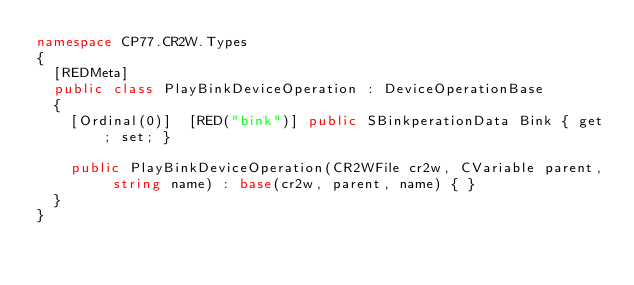Convert code to text. <code><loc_0><loc_0><loc_500><loc_500><_C#_>namespace CP77.CR2W.Types
{
	[REDMeta]
	public class PlayBinkDeviceOperation : DeviceOperationBase
	{
		[Ordinal(0)]  [RED("bink")] public SBinkperationData Bink { get; set; }

		public PlayBinkDeviceOperation(CR2WFile cr2w, CVariable parent, string name) : base(cr2w, parent, name) { }
	}
}
</code> 